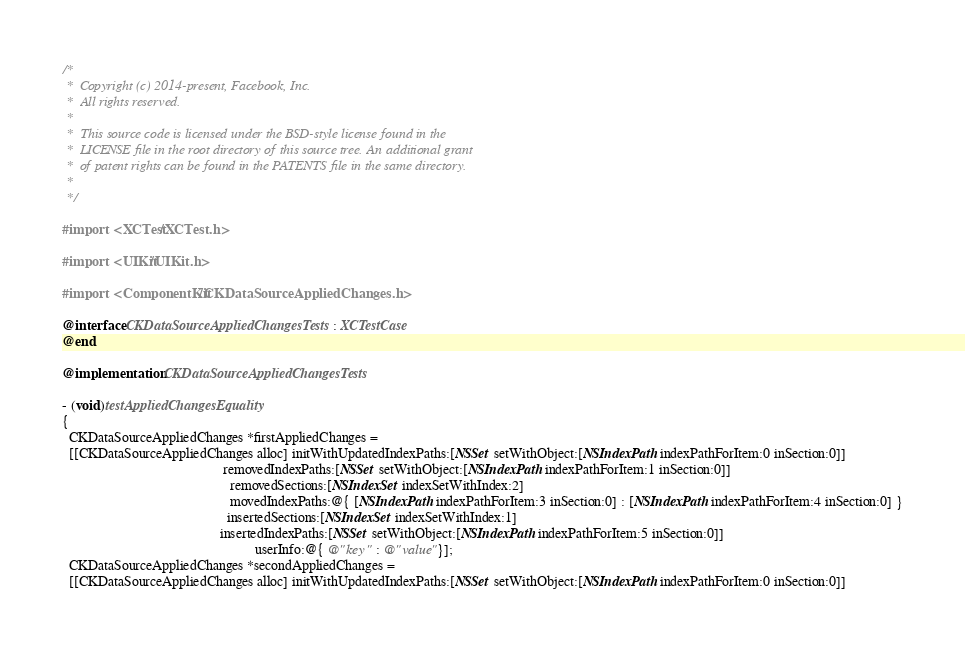<code> <loc_0><loc_0><loc_500><loc_500><_ObjectiveC_>/*
 *  Copyright (c) 2014-present, Facebook, Inc.
 *  All rights reserved.
 *
 *  This source code is licensed under the BSD-style license found in the
 *  LICENSE file in the root directory of this source tree. An additional grant
 *  of patent rights can be found in the PATENTS file in the same directory.
 *
 */

#import <XCTest/XCTest.h>

#import <UIKit/UIKit.h>

#import <ComponentKit/CKDataSourceAppliedChanges.h>

@interface CKDataSourceAppliedChangesTests : XCTestCase
@end

@implementation CKDataSourceAppliedChangesTests

- (void)testAppliedChangesEquality
{
  CKDataSourceAppliedChanges *firstAppliedChanges =
  [[CKDataSourceAppliedChanges alloc] initWithUpdatedIndexPaths:[NSSet setWithObject:[NSIndexPath indexPathForItem:0 inSection:0]]
                                              removedIndexPaths:[NSSet setWithObject:[NSIndexPath indexPathForItem:1 inSection:0]]
                                                removedSections:[NSIndexSet indexSetWithIndex:2]
                                                movedIndexPaths:@{ [NSIndexPath indexPathForItem:3 inSection:0] : [NSIndexPath indexPathForItem:4 inSection:0] }
                                               insertedSections:[NSIndexSet indexSetWithIndex:1]
                                             insertedIndexPaths:[NSSet setWithObject:[NSIndexPath indexPathForItem:5 inSection:0]]
                                                       userInfo:@{ @"key" : @"value"}];
  CKDataSourceAppliedChanges *secondAppliedChanges =
  [[CKDataSourceAppliedChanges alloc] initWithUpdatedIndexPaths:[NSSet setWithObject:[NSIndexPath indexPathForItem:0 inSection:0]]</code> 